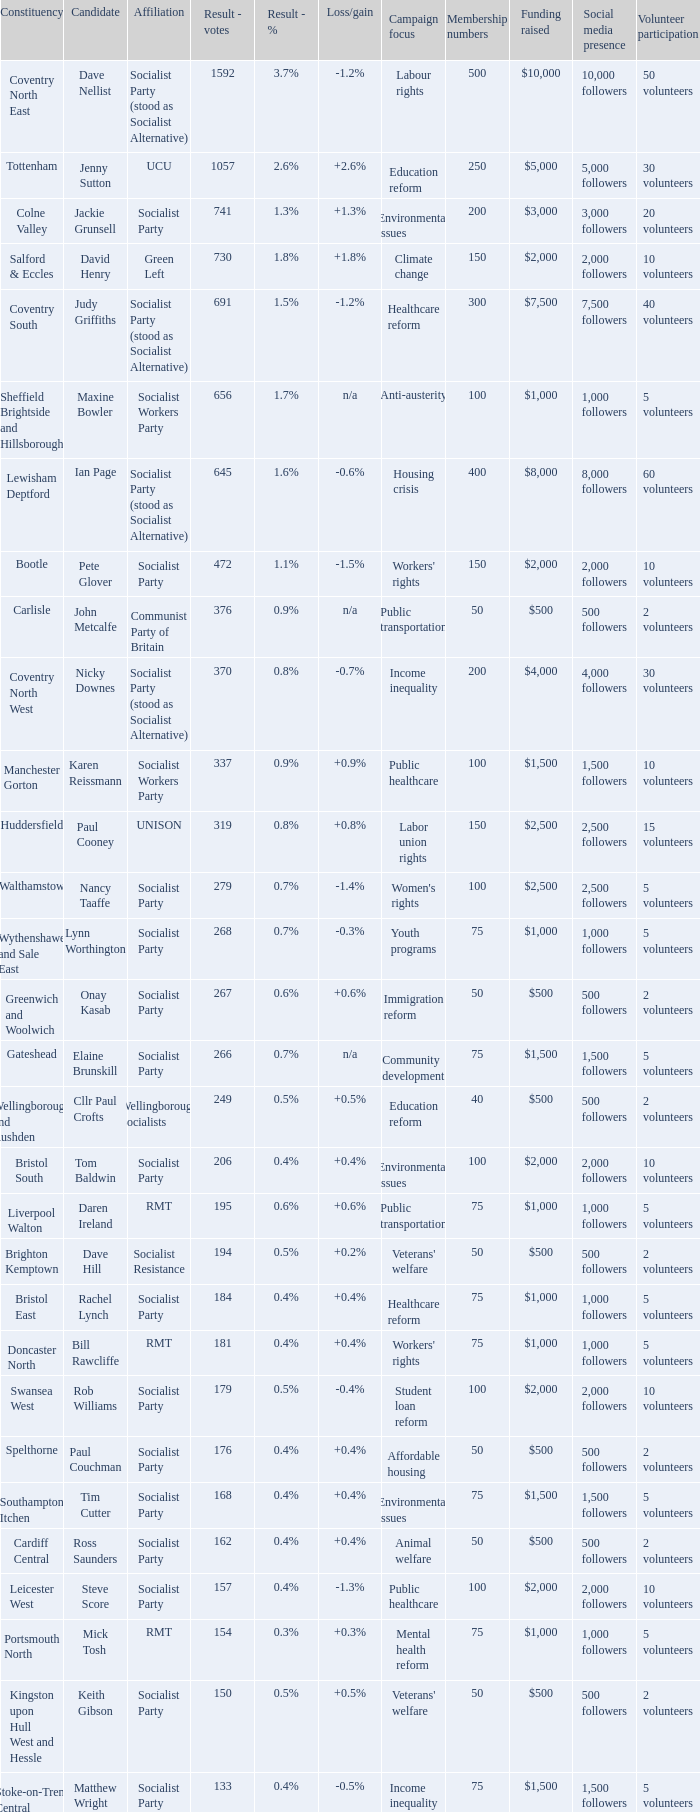What are all the ties for candidate daren ireland? RMT. 